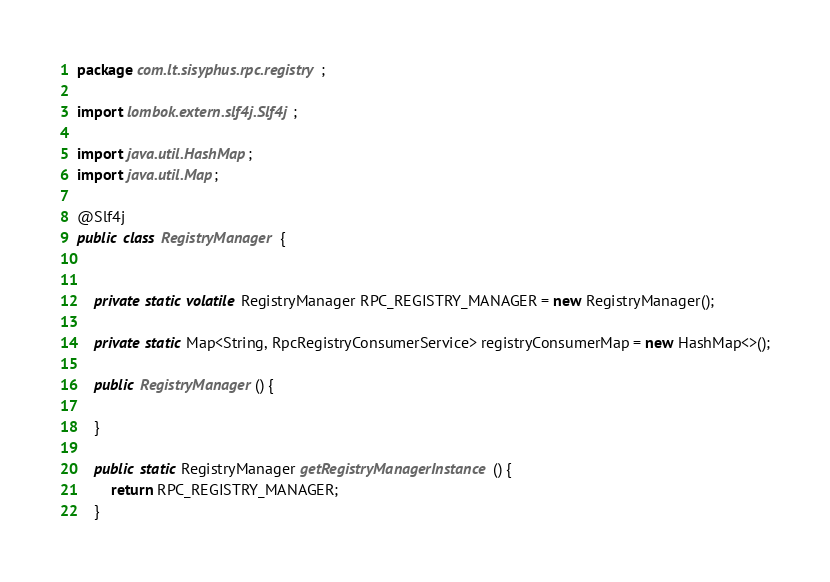<code> <loc_0><loc_0><loc_500><loc_500><_Java_>package com.lt.sisyphus.rpc.registry;

import lombok.extern.slf4j.Slf4j;

import java.util.HashMap;
import java.util.Map;

@Slf4j
public class RegistryManager {


    private static volatile RegistryManager RPC_REGISTRY_MANAGER = new RegistryManager();

    private static Map<String, RpcRegistryConsumerService> registryConsumerMap = new HashMap<>();

    public RegistryManager() {

    }

    public static RegistryManager getRegistryManagerInstance() {
        return RPC_REGISTRY_MANAGER;
    }
</code> 